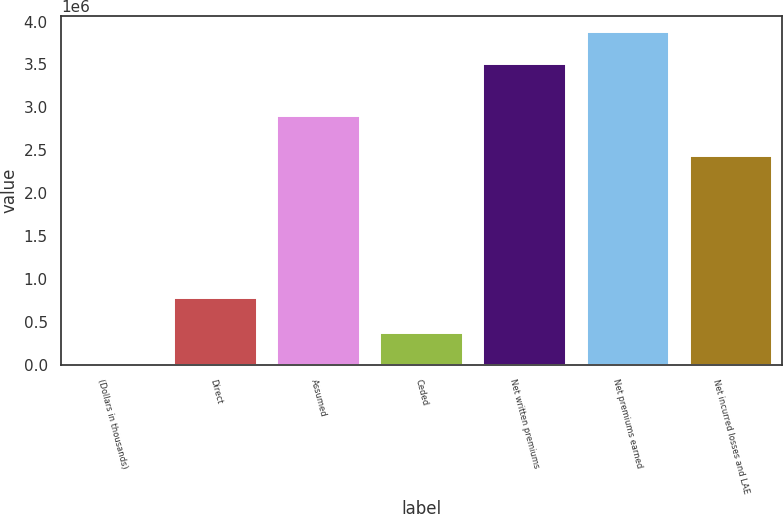<chart> <loc_0><loc_0><loc_500><loc_500><bar_chart><fcel>(Dollars in thousands)<fcel>Direct<fcel>Assumed<fcel>Ceded<fcel>Net written premiums<fcel>Net premiums earned<fcel>Net incurred losses and LAE<nl><fcel>2008<fcel>778597<fcel>2.89954e+06<fcel>371237<fcel>3.50521e+06<fcel>3.87444e+06<fcel>2.43897e+06<nl></chart> 